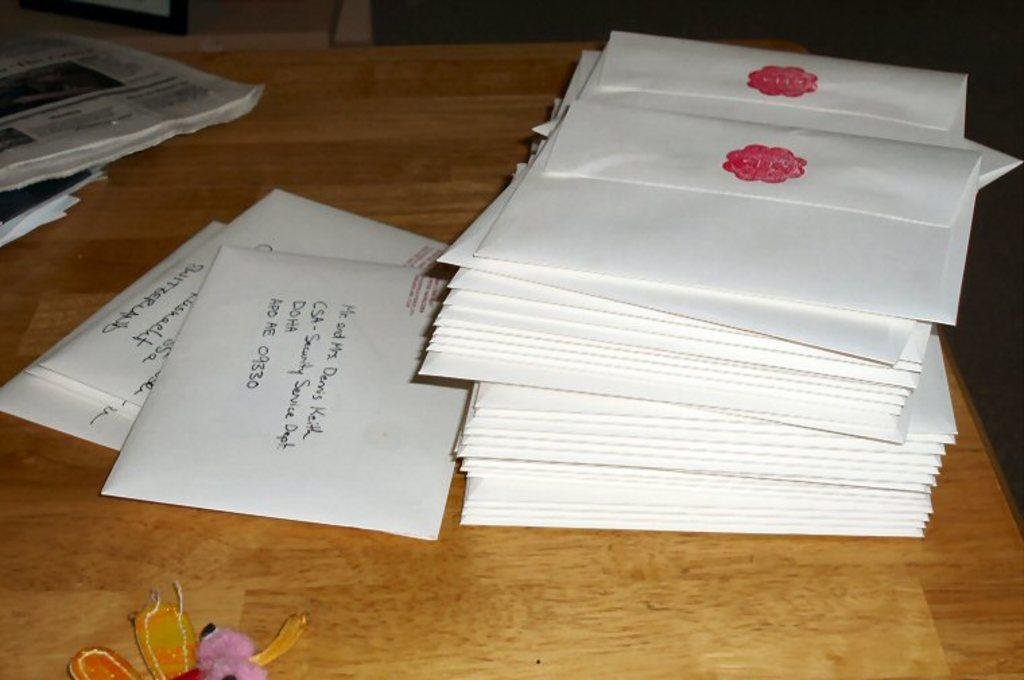<image>
Give a short and clear explanation of the subsequent image. Someone has addressed an envelope to be sent to zip code 09330. 